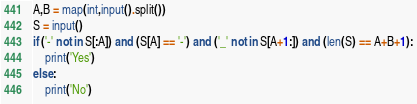<code> <loc_0><loc_0><loc_500><loc_500><_Python_>A,B = map(int,input().split())
S = input()
if ('-' not in S[:A]) and (S[A] == '-') and ('_' not in S[A+1:]) and (len(S) == A+B+1):
    print('Yes')
else:
    print('No')</code> 